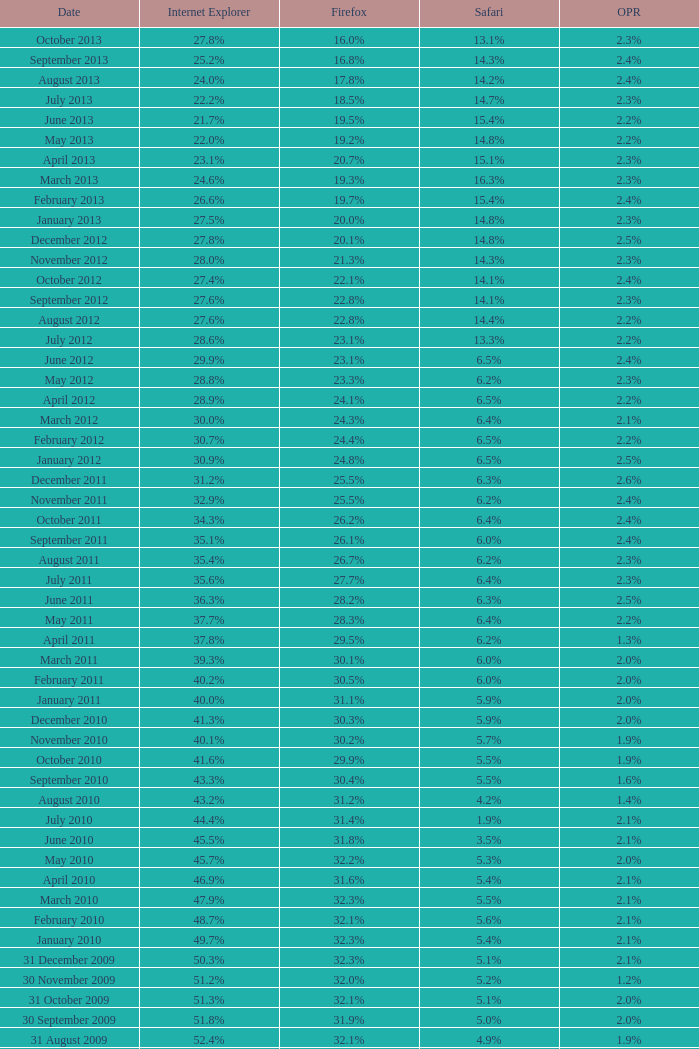What is the safari value with a 2.4% opera and 29.9% internet explorer? 6.5%. 